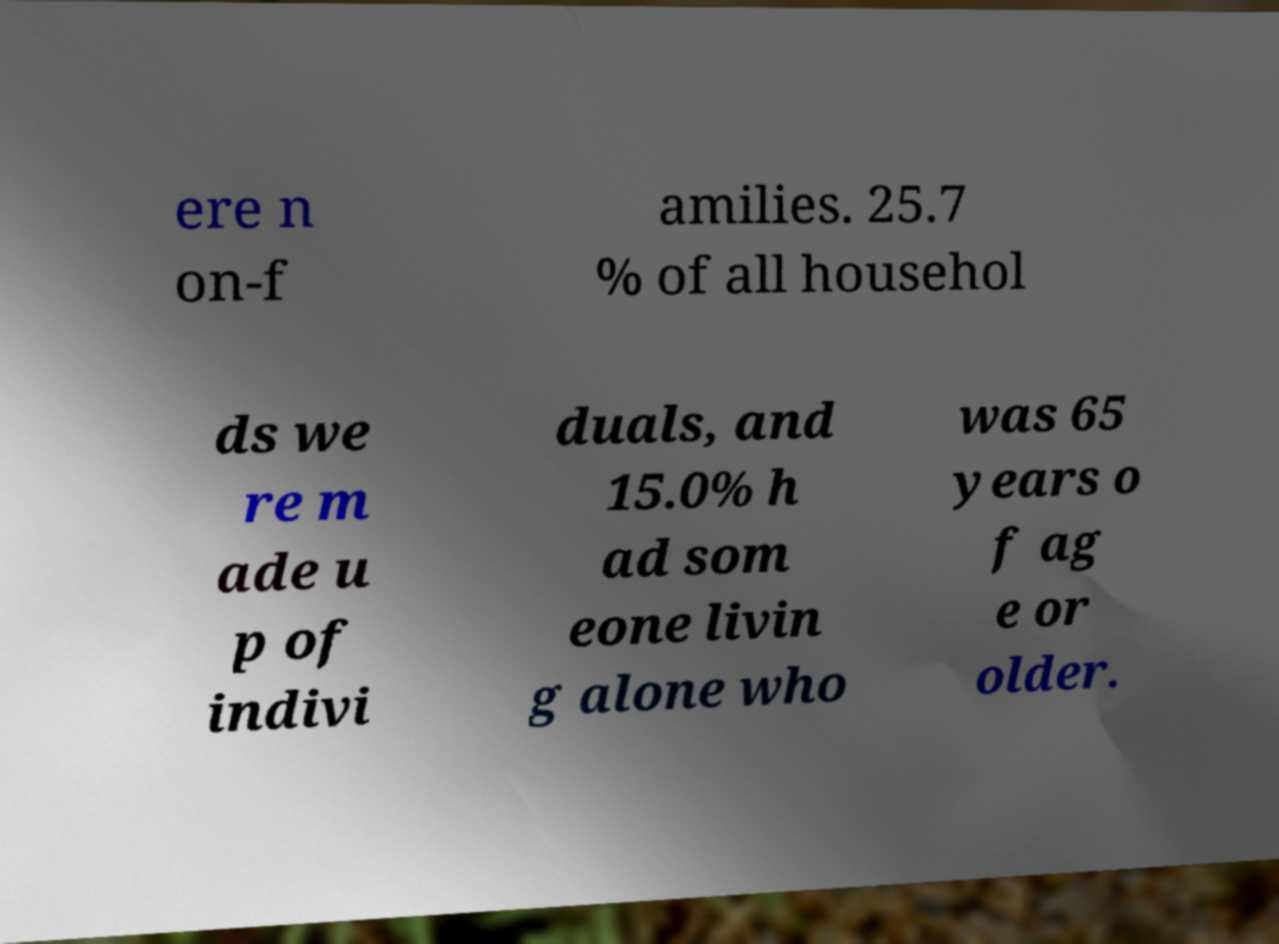Could you extract and type out the text from this image? ere n on-f amilies. 25.7 % of all househol ds we re m ade u p of indivi duals, and 15.0% h ad som eone livin g alone who was 65 years o f ag e or older. 